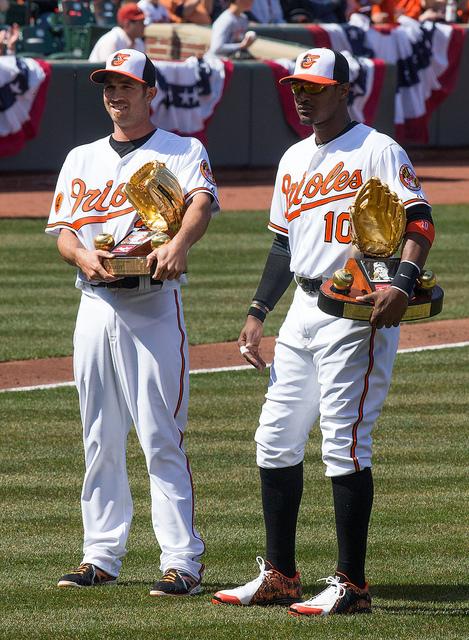What number is on the uniform of the man on the right side of the image?
Concise answer only. 10. Does one player have a free hand?
Give a very brief answer. Yes. Are the man wearing hats?
Be succinct. Yes. Where is the pitcher?
Short answer required. On field. 